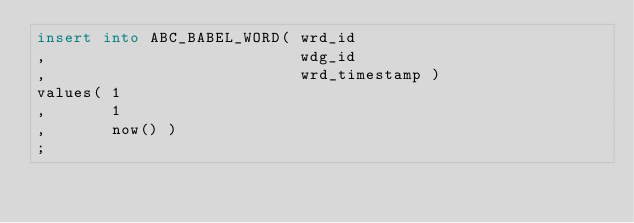Convert code to text. <code><loc_0><loc_0><loc_500><loc_500><_SQL_>insert into ABC_BABEL_WORD( wrd_id
,                           wdg_id
,                           wrd_timestamp )
values( 1
,       1
,       now() )
;
</code> 